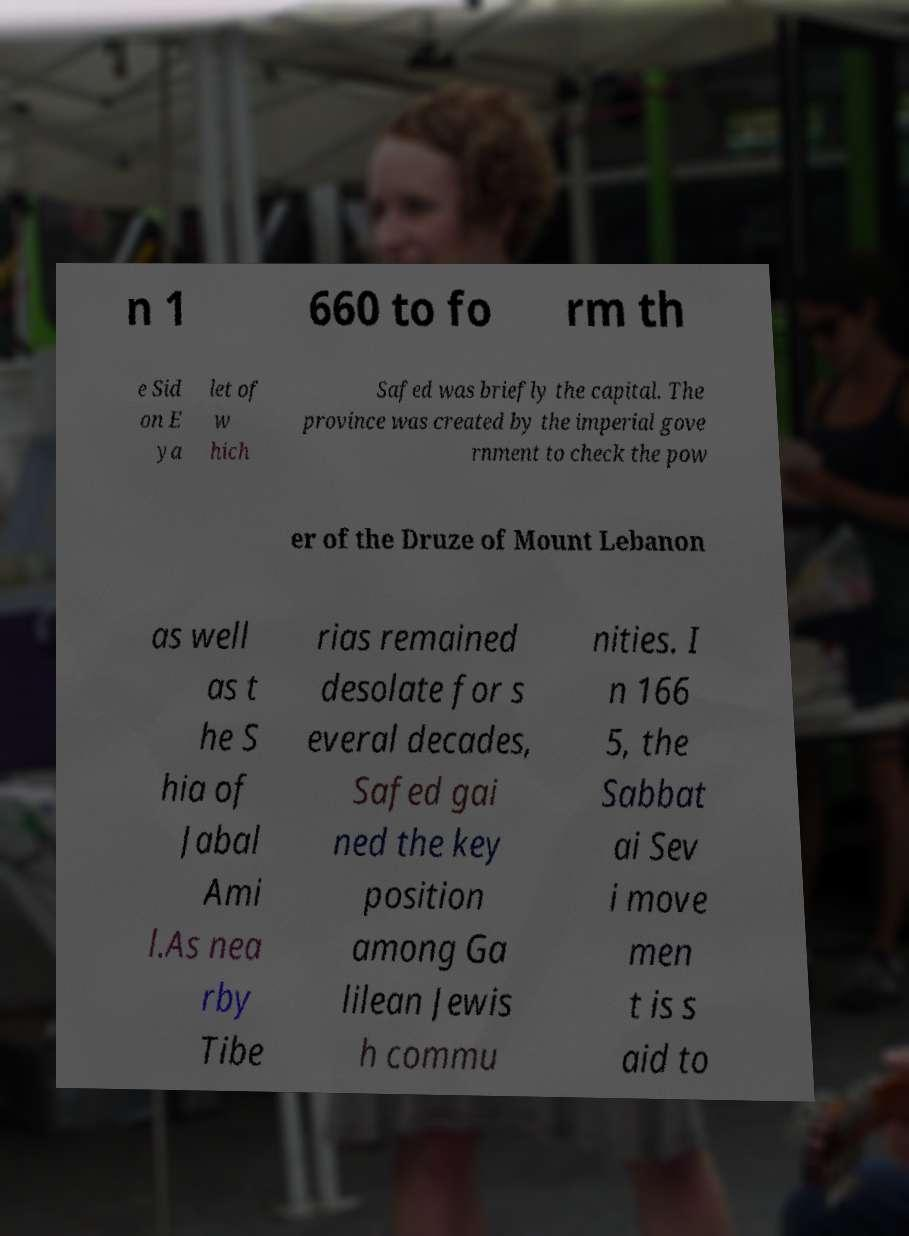I need the written content from this picture converted into text. Can you do that? n 1 660 to fo rm th e Sid on E ya let of w hich Safed was briefly the capital. The province was created by the imperial gove rnment to check the pow er of the Druze of Mount Lebanon as well as t he S hia of Jabal Ami l.As nea rby Tibe rias remained desolate for s everal decades, Safed gai ned the key position among Ga lilean Jewis h commu nities. I n 166 5, the Sabbat ai Sev i move men t is s aid to 